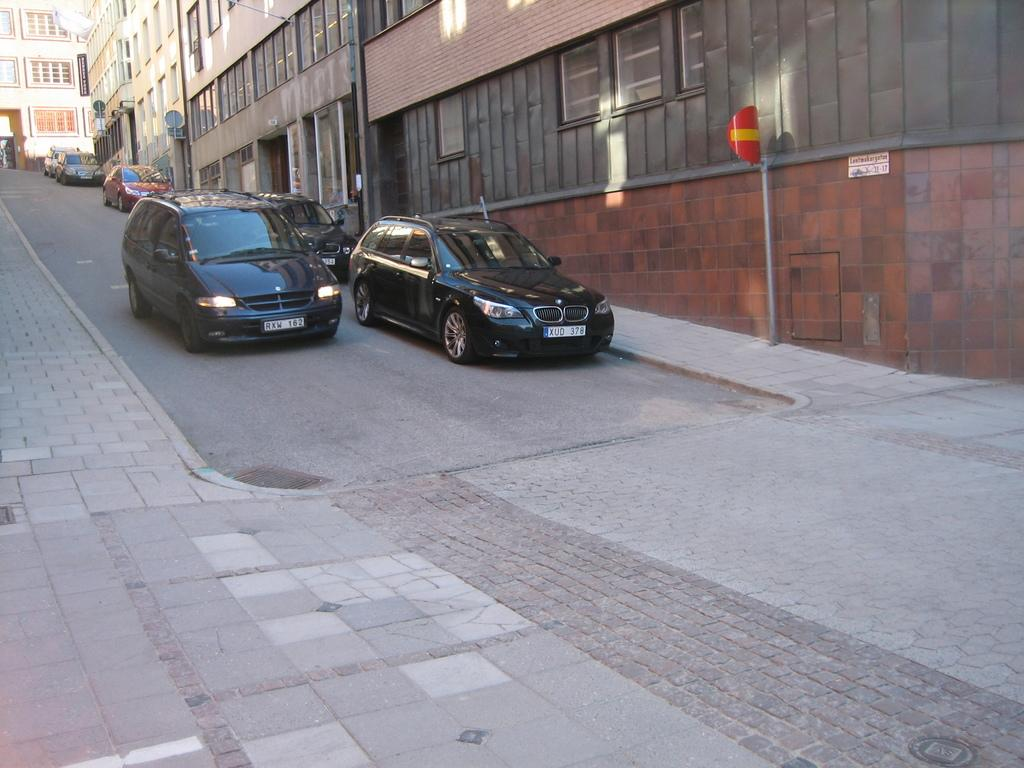What can be seen on the right side of the road in the image? There are cars parked on the right side of the road. What type of structures are visible in the image? There are buildings with windows in the image. What type of religion is being practiced in the image? There is no indication of any religious practice in the image. What type of teeth can be seen in the image? There are no teeth visible in the image. 